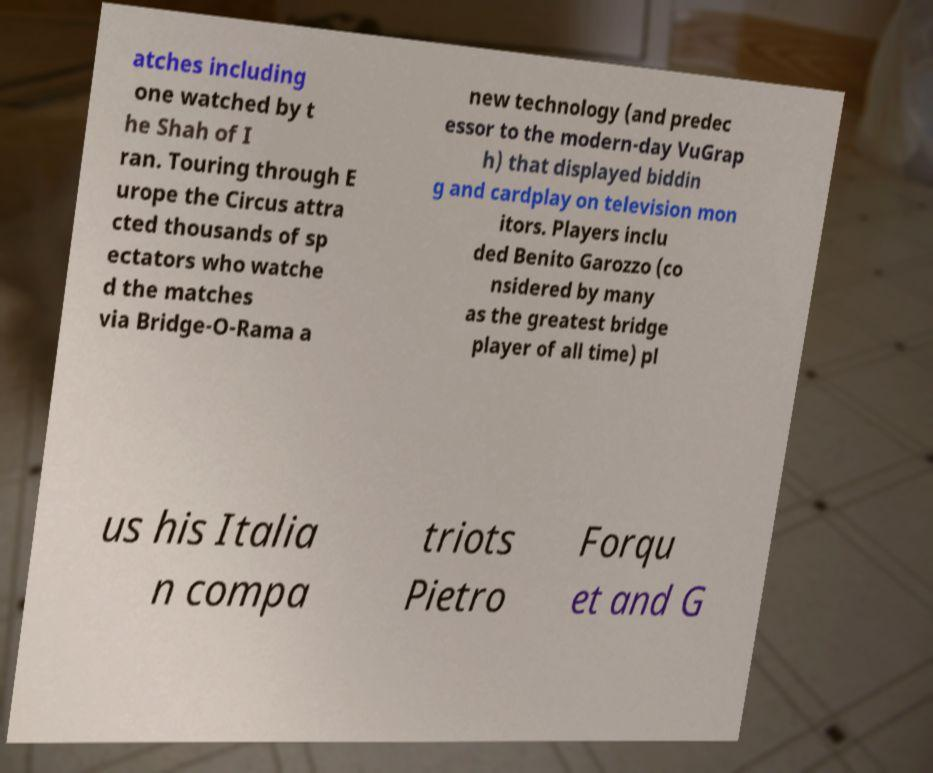Could you extract and type out the text from this image? atches including one watched by t he Shah of I ran. Touring through E urope the Circus attra cted thousands of sp ectators who watche d the matches via Bridge-O-Rama a new technology (and predec essor to the modern-day VuGrap h) that displayed biddin g and cardplay on television mon itors. Players inclu ded Benito Garozzo (co nsidered by many as the greatest bridge player of all time) pl us his Italia n compa triots Pietro Forqu et and G 